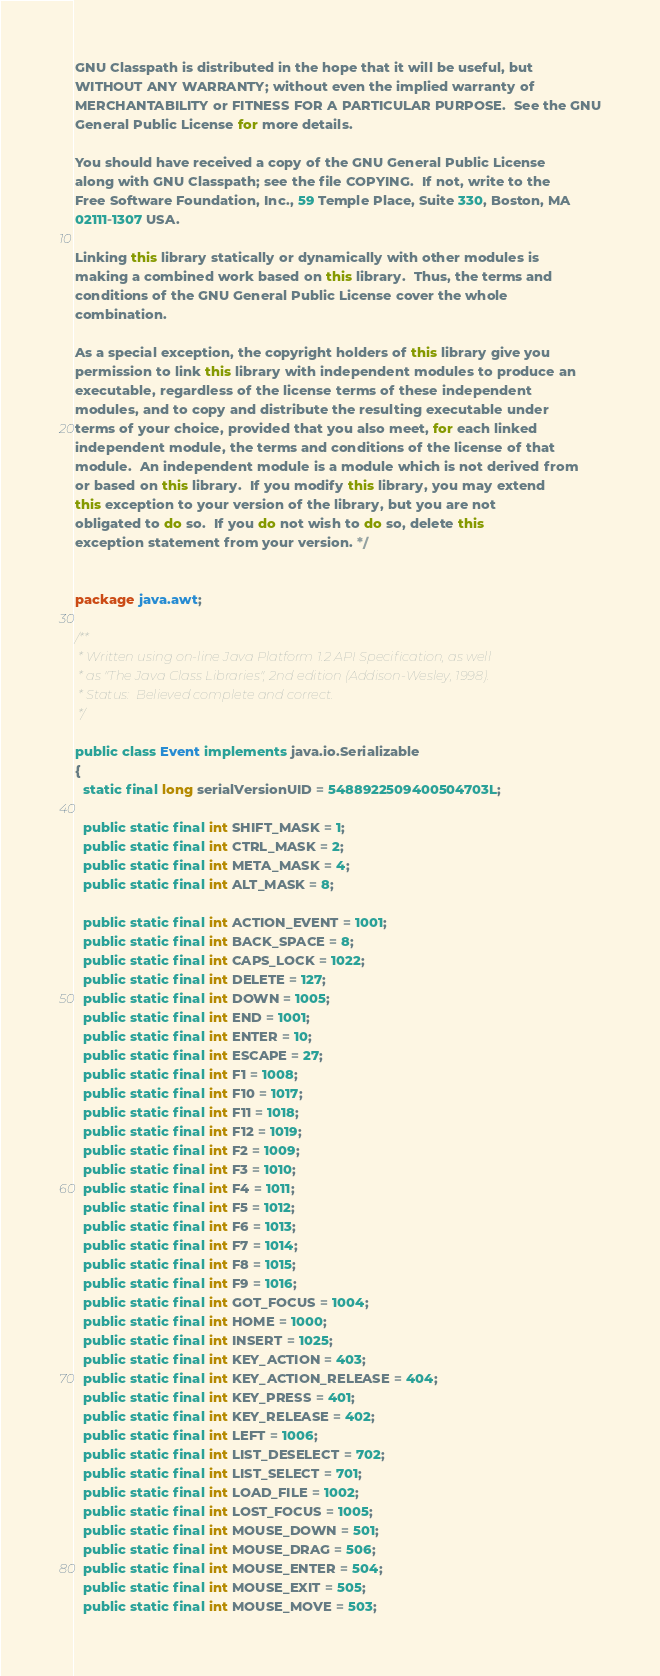<code> <loc_0><loc_0><loc_500><loc_500><_Java_>
GNU Classpath is distributed in the hope that it will be useful, but
WITHOUT ANY WARRANTY; without even the implied warranty of
MERCHANTABILITY or FITNESS FOR A PARTICULAR PURPOSE.  See the GNU
General Public License for more details.

You should have received a copy of the GNU General Public License
along with GNU Classpath; see the file COPYING.  If not, write to the
Free Software Foundation, Inc., 59 Temple Place, Suite 330, Boston, MA
02111-1307 USA.

Linking this library statically or dynamically with other modules is
making a combined work based on this library.  Thus, the terms and
conditions of the GNU General Public License cover the whole
combination.

As a special exception, the copyright holders of this library give you
permission to link this library with independent modules to produce an
executable, regardless of the license terms of these independent
modules, and to copy and distribute the resulting executable under
terms of your choice, provided that you also meet, for each linked
independent module, the terms and conditions of the license of that
module.  An independent module is a module which is not derived from
or based on this library.  If you modify this library, you may extend
this exception to your version of the library, but you are not
obligated to do so.  If you do not wish to do so, delete this
exception statement from your version. */


package java.awt;

/**
 * Written using on-line Java Platform 1.2 API Specification, as well
 * as "The Java Class Libraries", 2nd edition (Addison-Wesley, 1998).
 * Status:  Believed complete and correct.
 */

public class Event implements java.io.Serializable
{
  static final long serialVersionUID = 5488922509400504703L;

  public static final int SHIFT_MASK = 1;
  public static final int CTRL_MASK = 2;
  public static final int META_MASK = 4;
  public static final int ALT_MASK = 8;

  public static final int ACTION_EVENT = 1001;
  public static final int BACK_SPACE = 8;
  public static final int CAPS_LOCK = 1022;
  public static final int DELETE = 127;
  public static final int DOWN = 1005;
  public static final int END = 1001;
  public static final int ENTER = 10;
  public static final int ESCAPE = 27;
  public static final int F1 = 1008;
  public static final int F10 = 1017;
  public static final int F11 = 1018;
  public static final int F12 = 1019;
  public static final int F2 = 1009;
  public static final int F3 = 1010;
  public static final int F4 = 1011;
  public static final int F5 = 1012;
  public static final int F6 = 1013;
  public static final int F7 = 1014;
  public static final int F8 = 1015;
  public static final int F9 = 1016;
  public static final int GOT_FOCUS = 1004;
  public static final int HOME = 1000;
  public static final int INSERT = 1025;
  public static final int KEY_ACTION = 403;
  public static final int KEY_ACTION_RELEASE = 404;
  public static final int KEY_PRESS = 401;
  public static final int KEY_RELEASE = 402;
  public static final int LEFT = 1006;
  public static final int LIST_DESELECT = 702;
  public static final int LIST_SELECT = 701;
  public static final int LOAD_FILE = 1002;
  public static final int LOST_FOCUS = 1005;
  public static final int MOUSE_DOWN = 501;
  public static final int MOUSE_DRAG = 506;
  public static final int MOUSE_ENTER = 504;
  public static final int MOUSE_EXIT = 505;
  public static final int MOUSE_MOVE = 503;</code> 